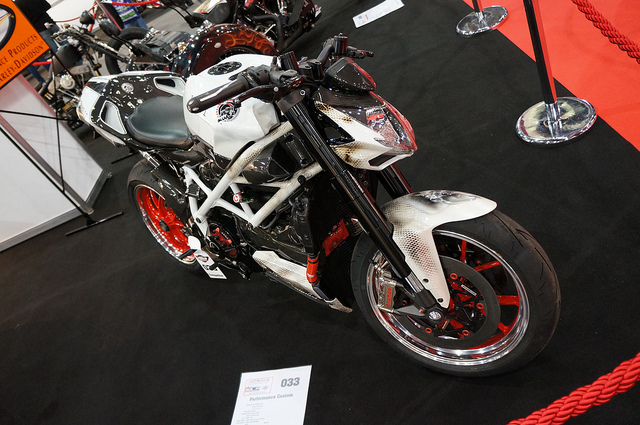Read and extract the text from this image. PRODUCTS DAVIDSON 033 